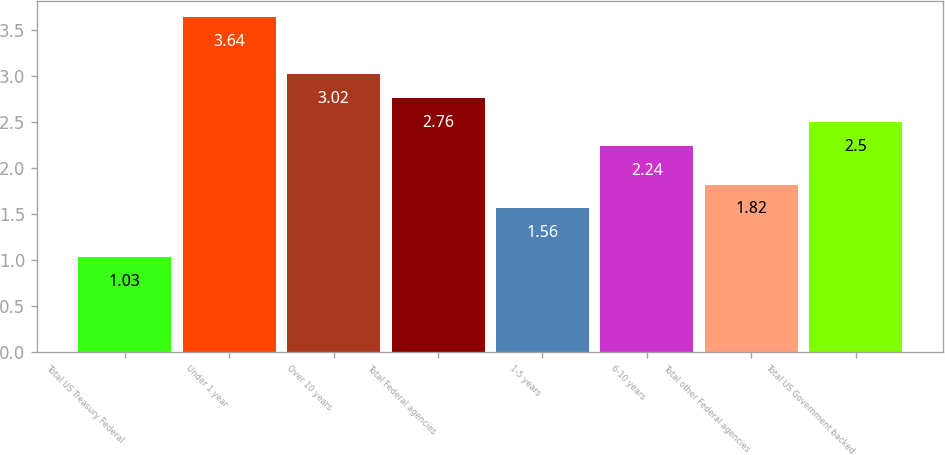Convert chart to OTSL. <chart><loc_0><loc_0><loc_500><loc_500><bar_chart><fcel>Total US Treasury Federal<fcel>Under 1 year<fcel>Over 10 years<fcel>Total Federal agencies<fcel>1-5 years<fcel>6-10 years<fcel>Total other Federal agencies<fcel>Total US Government backed<nl><fcel>1.03<fcel>3.64<fcel>3.02<fcel>2.76<fcel>1.56<fcel>2.24<fcel>1.82<fcel>2.5<nl></chart> 